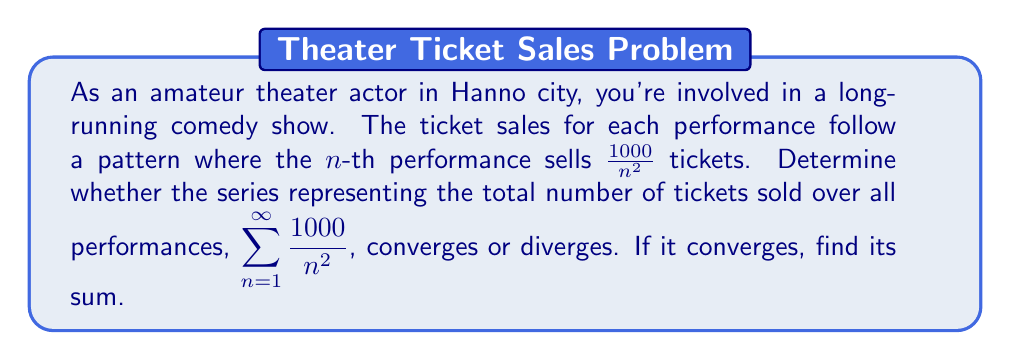Help me with this question. Let's approach this step-by-step:

1) First, we need to recognize that this series is a constant multiple of a well-known series. We can factor out 1000:

   $$\sum_{n=1}^{\infty} \frac{1000}{n^2} = 1000 \sum_{n=1}^{\infty} \frac{1}{n^2}$$

2) The series $\sum_{n=1}^{\infty} \frac{1}{n^2}$ is a p-series with $p = 2$. We know that p-series converge for $p > 1$.

3) Since $2 > 1$, we can conclude that $\sum_{n=1}^{\infty} \frac{1}{n^2}$ converges.

4) If a series converges, any constant multiple of that series also converges. Therefore, $1000 \sum_{n=1}^{\infty} \frac{1}{n^2}$ also converges.

5) To find the sum, we can use the known result for the sum of $\sum_{n=1}^{\infty} \frac{1}{n^2}$:

   $$\sum_{n=1}^{\infty} \frac{1}{n^2} = \frac{\pi^2}{6}$$

6) Therefore, the sum of our series is:

   $$1000 \sum_{n=1}^{\infty} \frac{1}{n^2} = 1000 \cdot \frac{\pi^2}{6} = \frac{1000\pi^2}{6}$$

Thus, the series converges to $\frac{1000\pi^2}{6}$.
Answer: The series converges, and its sum is $\frac{1000\pi^2}{6}$. 